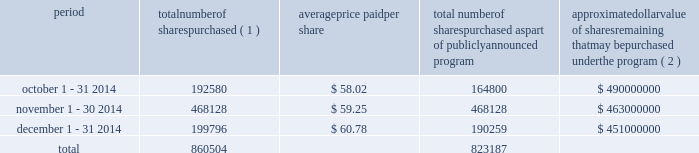Celanese purchases of its equity securities information regarding repurchases of our common stock during the three months ended december 31 , 2014 is as follows : period number of shares purchased ( 1 ) average price paid per share total number of shares purchased as part of publicly announced program approximate dollar value of shares remaining that may be purchased under the program ( 2 ) .
___________________________ ( 1 ) includes 27780 and 9537 for october and december 2014 , respectively , related to shares withheld from employees to cover their statutory minimum withholding requirements for personal income taxes related to the vesting of restricted stock units .
( 2 ) our board of directors has authorized the aggregate repurchase of $ 1.4 billion of our common stock since february 2008 .
See note 17 - stockholders' equity in the accompanying consolidated financial statements for further information .
Performance graph the following performance graph and related information shall not be deemed "soliciting material" or to be "filed" with the securities and exchange commission , nor shall such information be incorporated by reference into any future filing under the securities act of 1933 or securities exchange act of 1934 , each as amended , except to the extent that we specifically incorporate it by reference into such filing .
Comparison of cumulative total return .
What is the total value paid for purchased shares during december 2014? 
Computations: ((199796 * 60.78) / 1000000)
Answer: 12.1436. Celanese purchases of its equity securities information regarding repurchases of our common stock during the three months ended december 31 , 2014 is as follows : period number of shares purchased ( 1 ) average price paid per share total number of shares purchased as part of publicly announced program approximate dollar value of shares remaining that may be purchased under the program ( 2 ) .
___________________________ ( 1 ) includes 27780 and 9537 for october and december 2014 , respectively , related to shares withheld from employees to cover their statutory minimum withholding requirements for personal income taxes related to the vesting of restricted stock units .
( 2 ) our board of directors has authorized the aggregate repurchase of $ 1.4 billion of our common stock since february 2008 .
See note 17 - stockholders' equity in the accompanying consolidated financial statements for further information .
Performance graph the following performance graph and related information shall not be deemed "soliciting material" or to be "filed" with the securities and exchange commission , nor shall such information be incorporated by reference into any future filing under the securities act of 1933 or securities exchange act of 1934 , each as amended , except to the extent that we specifically incorporate it by reference into such filing .
Comparison of cumulative total return .
In 2014 for the period october 1 - 31 2014 what was the ratio of the shares purchased as part of publicly announced program to the total number of shares purchased? 
Rationale: for every dollar spent on shares purchase ( 1 ) $ 0.86 went to the shares purchased as part of publicly announced program
Computations: (164800 / 192580)
Answer: 0.85575. 